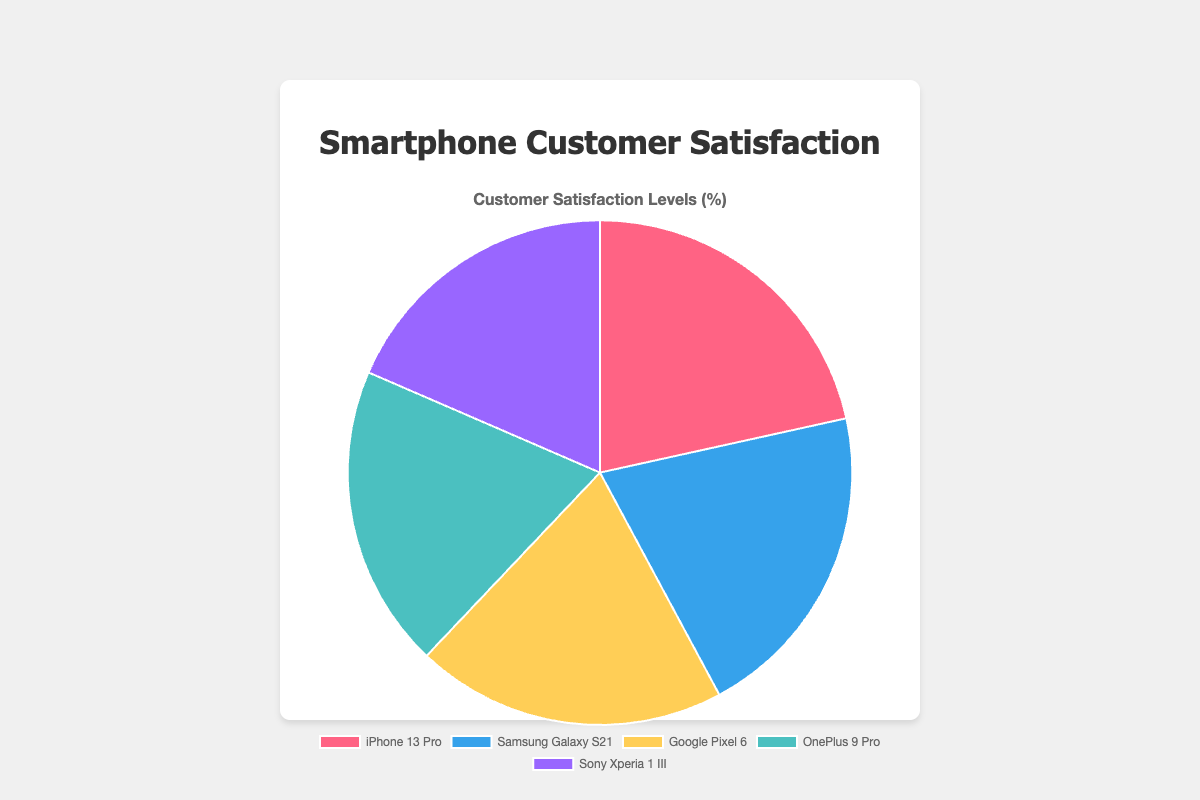What percentage of customer satisfaction is attributed to the iPhone 13 Pro? The iPhone 13 Pro has a satisfaction level of 92%, as indicated by its slice of the pie chart.
Answer: 92% Among the listed smartphone models, which one has the lowest customer satisfaction level? The Sony Xperia 1 III has the lowest customer satisfaction level with a value of 79%, as it occupies the smallest slice of the pie chart.
Answer: Sony Xperia 1 III Which two smartphone models combined have a satisfaction level closest to 170%? Adding the satisfaction levels of the Samsung Galaxy S21 (88%) and Google Pixel 6 (85%) gives a total of 173%, which is closest to 170%.
Answer: Samsung Galaxy S21 and Google Pixel 6 How much greater is the satisfaction level of the iPhone 13 Pro compared to the Sony Xperia 1 III? Subtract the satisfaction level of the Sony Xperia 1 III (79%) from that of the iPhone 13 Pro (92%) to find the difference. 92% - 79% = 13%.
Answer: 13% Rank the smartphone models from highest to lowest customer satisfaction levels. The rankings based on the satisfaction levels are as follows: iPhone 13 Pro (92%), Samsung Galaxy S21 (88%), Google Pixel 6 (85%), OnePlus 9 Pro (83%), and Sony Xperia 1 III (79%).
Answer: iPhone 13 Pro, Samsung Galaxy S21, Google Pixel 6, OnePlus 9 Pro, Sony Xperia 1 III Is the satisfaction level of the OnePlus 9 Pro higher or lower than the average satisfaction level of all five models? First, calculate the average satisfaction level: (92 + 88 + 85 + 83 + 79) / 5 = 85.4%. The OnePlus 9 Pro has a satisfaction level of 83%, which is lower than the average of 85.4%.
Answer: Lower What is the combined customer satisfaction level for the Google Pixel 6 and OnePlus 9 Pro? Adding their satisfaction levels gives 85% + 83% = 168%.
Answer: 168% Which smartphone model has the second-highest customer satisfaction level? The Samsung Galaxy S21 has the second-highest customer satisfaction level with 88%.
Answer: Samsung Galaxy S21 What is the difference in satisfaction levels between the Samsung Galaxy S21 and OnePlus 9 Pro? Subtract the satisfaction level of the OnePlus 9 Pro (83%) from that of the Samsung Galaxy S21 (88%): 88% - 83% = 5%.
Answer: 5% What color represents the Google Pixel 6 in the pie chart? The chart uses natural colors: the Google Pixel 6 is represented in yellow, as per the color code used in the dataset.
Answer: Yellow 